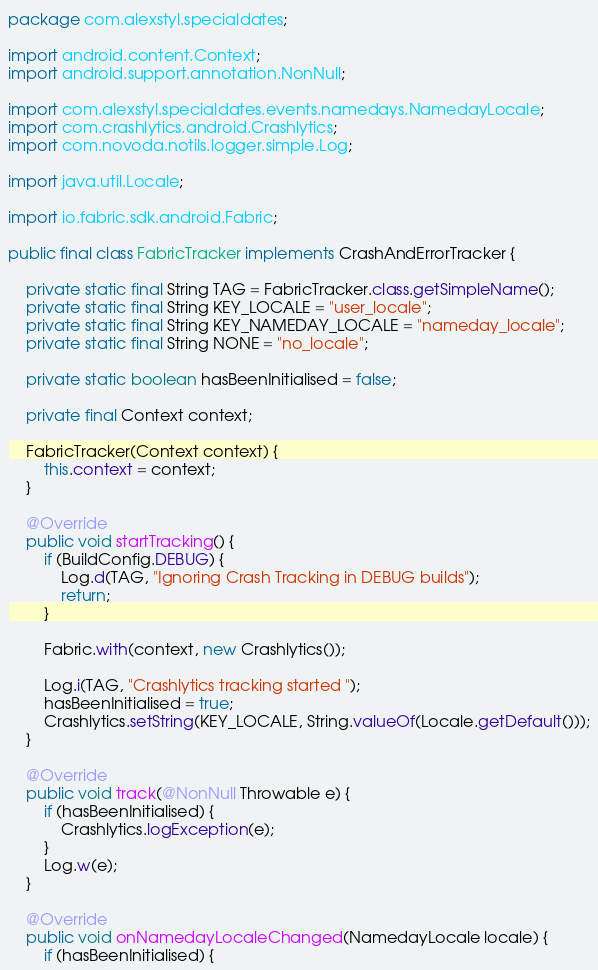Convert code to text. <code><loc_0><loc_0><loc_500><loc_500><_Java_>package com.alexstyl.specialdates;

import android.content.Context;
import android.support.annotation.NonNull;

import com.alexstyl.specialdates.events.namedays.NamedayLocale;
import com.crashlytics.android.Crashlytics;
import com.novoda.notils.logger.simple.Log;

import java.util.Locale;

import io.fabric.sdk.android.Fabric;

public final class FabricTracker implements CrashAndErrorTracker {

    private static final String TAG = FabricTracker.class.getSimpleName();
    private static final String KEY_LOCALE = "user_locale";
    private static final String KEY_NAMEDAY_LOCALE = "nameday_locale";
    private static final String NONE = "no_locale";

    private static boolean hasBeenInitialised = false;

    private final Context context;

    FabricTracker(Context context) {
        this.context = context;
    }

    @Override
    public void startTracking() {
        if (BuildConfig.DEBUG) {
            Log.d(TAG, "Ignoring Crash Tracking in DEBUG builds");
            return;
        }

        Fabric.with(context, new Crashlytics());

        Log.i(TAG, "Crashlytics tracking started ");
        hasBeenInitialised = true;
        Crashlytics.setString(KEY_LOCALE, String.valueOf(Locale.getDefault()));
    }

    @Override
    public void track(@NonNull Throwable e) {
        if (hasBeenInitialised) {
            Crashlytics.logException(e);
        }
        Log.w(e);
    }

    @Override
    public void onNamedayLocaleChanged(NamedayLocale locale) {
        if (hasBeenInitialised) {</code> 